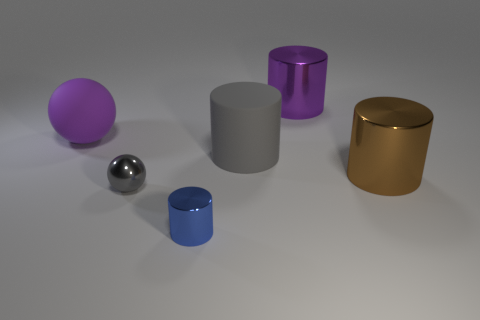What is the shape of the rubber thing that is in front of the large purple object that is on the left side of the large purple cylinder that is to the right of the gray rubber cylinder?
Make the answer very short. Cylinder. There is a cylinder that is right of the gray rubber object and behind the big brown cylinder; what is it made of?
Provide a succinct answer. Metal. Do the shiny cylinder that is behind the brown thing and the purple ball have the same size?
Your answer should be very brief. Yes. Are there more brown metallic cylinders right of the big purple rubber sphere than purple balls that are right of the brown cylinder?
Provide a short and direct response. Yes. There is a big shiny cylinder in front of the big cylinder that is behind the matte object to the left of the matte cylinder; what color is it?
Your response must be concise. Brown. Do the rubber thing on the right side of the small ball and the small metallic ball have the same color?
Provide a short and direct response. Yes. What number of other objects are there of the same color as the tiny metal ball?
Make the answer very short. 1. How many things are either small objects or blue objects?
Keep it short and to the point. 2. What number of objects are either small cyan metallic balls or cylinders that are right of the tiny cylinder?
Your response must be concise. 3. Is the purple cylinder made of the same material as the big sphere?
Your answer should be compact. No. 